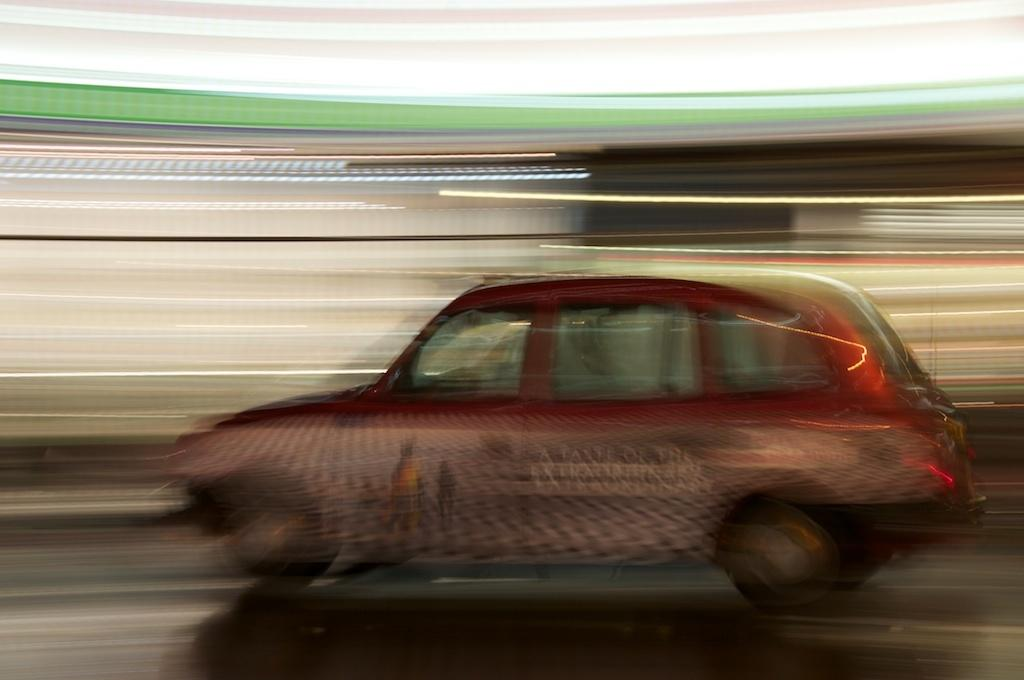What is the main subject of the image? The main subject of the image is a car. What is the car doing in the image? The car is passing on the road. What type of building can be seen on the edge of the road in the image? There is no building visible in the image; it only shows a car passing on the road. 